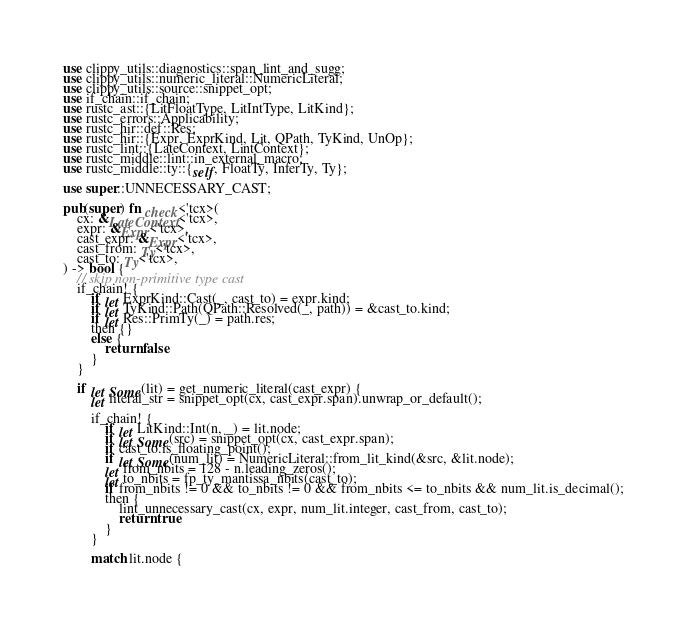Convert code to text. <code><loc_0><loc_0><loc_500><loc_500><_Rust_>use clippy_utils::diagnostics::span_lint_and_sugg;
use clippy_utils::numeric_literal::NumericLiteral;
use clippy_utils::source::snippet_opt;
use if_chain::if_chain;
use rustc_ast::{LitFloatType, LitIntType, LitKind};
use rustc_errors::Applicability;
use rustc_hir::def::Res;
use rustc_hir::{Expr, ExprKind, Lit, QPath, TyKind, UnOp};
use rustc_lint::{LateContext, LintContext};
use rustc_middle::lint::in_external_macro;
use rustc_middle::ty::{self, FloatTy, InferTy, Ty};

use super::UNNECESSARY_CAST;

pub(super) fn check<'tcx>(
    cx: &LateContext<'tcx>,
    expr: &Expr<'tcx>,
    cast_expr: &Expr<'tcx>,
    cast_from: Ty<'tcx>,
    cast_to: Ty<'tcx>,
) -> bool {
    // skip non-primitive type cast
    if_chain! {
        if let ExprKind::Cast(_, cast_to) = expr.kind;
        if let TyKind::Path(QPath::Resolved(_, path)) = &cast_to.kind;
        if let Res::PrimTy(_) = path.res;
        then {}
        else {
            return false
        }
    }

    if let Some(lit) = get_numeric_literal(cast_expr) {
        let literal_str = snippet_opt(cx, cast_expr.span).unwrap_or_default();

        if_chain! {
            if let LitKind::Int(n, _) = lit.node;
            if let Some(src) = snippet_opt(cx, cast_expr.span);
            if cast_to.is_floating_point();
            if let Some(num_lit) = NumericLiteral::from_lit_kind(&src, &lit.node);
            let from_nbits = 128 - n.leading_zeros();
            let to_nbits = fp_ty_mantissa_nbits(cast_to);
            if from_nbits != 0 && to_nbits != 0 && from_nbits <= to_nbits && num_lit.is_decimal();
            then {
                lint_unnecessary_cast(cx, expr, num_lit.integer, cast_from, cast_to);
                return true
            }
        }

        match lit.node {</code> 